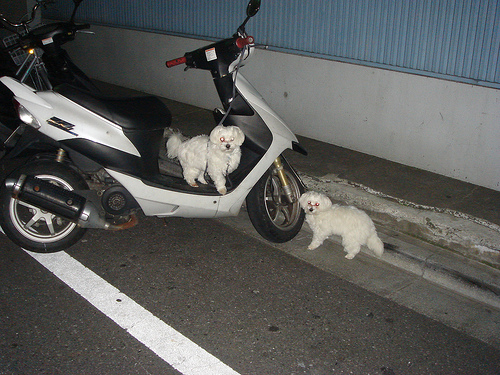Please provide the bounding box coordinate of the region this sentence describes: back tyre of the bike. The back tyre of the bike is observed in the lower-left portion of the image, specifically in the region [0.02, 0.46, 0.18, 0.61], set beside the motorcycle's structure near the center. 